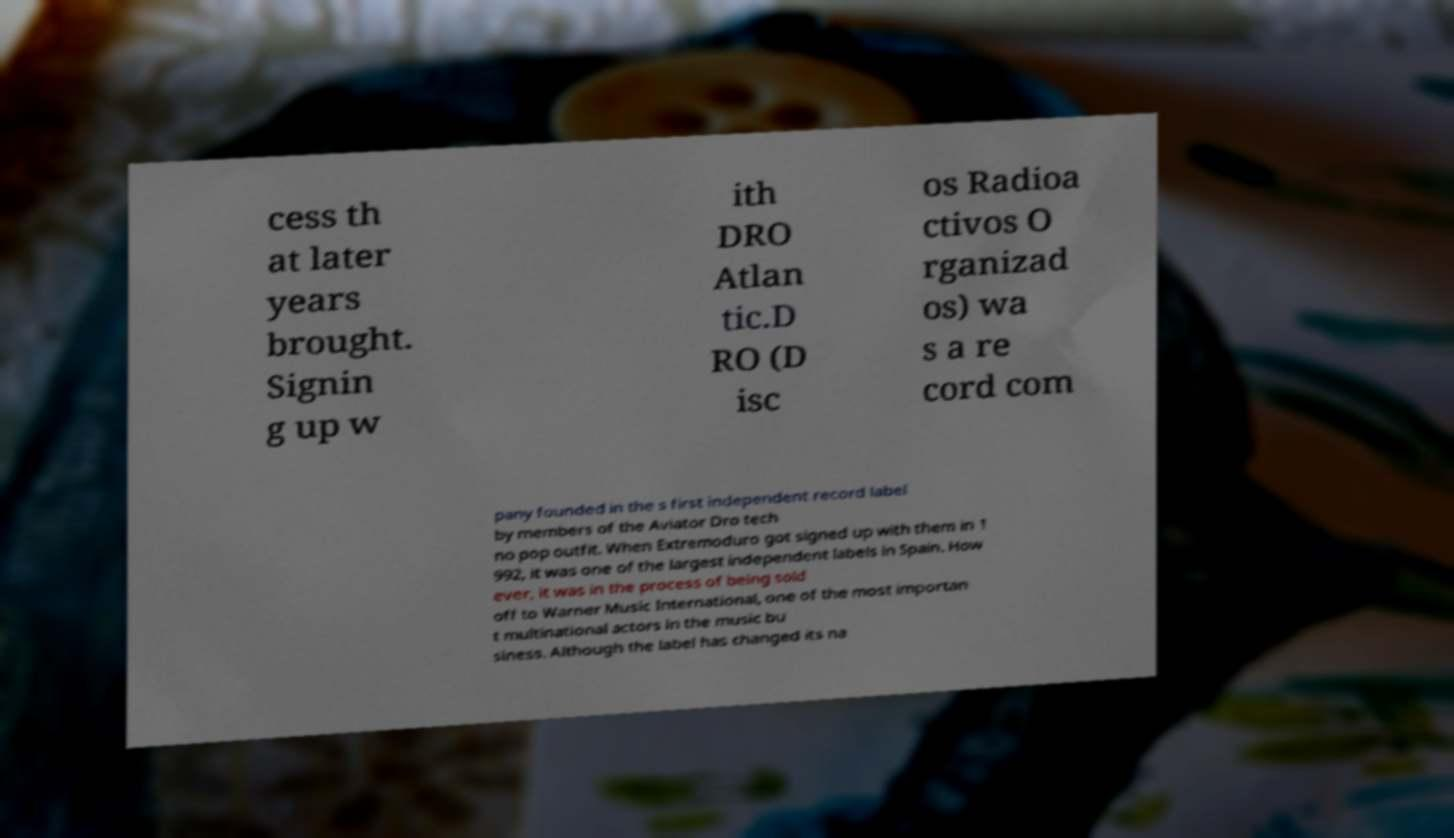Can you accurately transcribe the text from the provided image for me? cess th at later years brought. Signin g up w ith DRO Atlan tic.D RO (D isc os Radioa ctivos O rganizad os) wa s a re cord com pany founded in the s first independent record label by members of the Aviator Dro tech no pop outfit. When Extremoduro got signed up with them in 1 992, it was one of the largest independent labels in Spain. How ever, it was in the process of being sold off to Warner Music International, one of the most importan t multinational actors in the music bu siness. Although the label has changed its na 